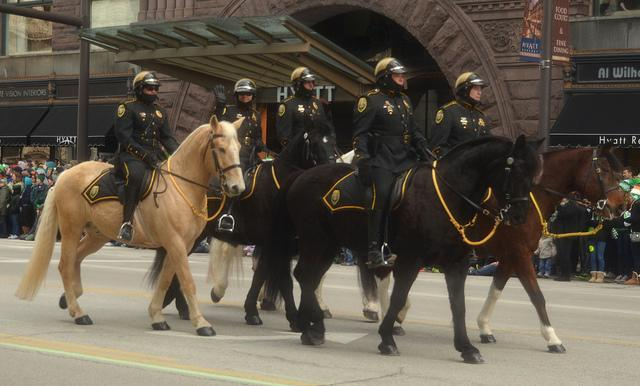What hotel is in the background behind the policemen and horses?

Choices:
A) best western
B) hilton
C) wyndham
D) hyatt hyatt 